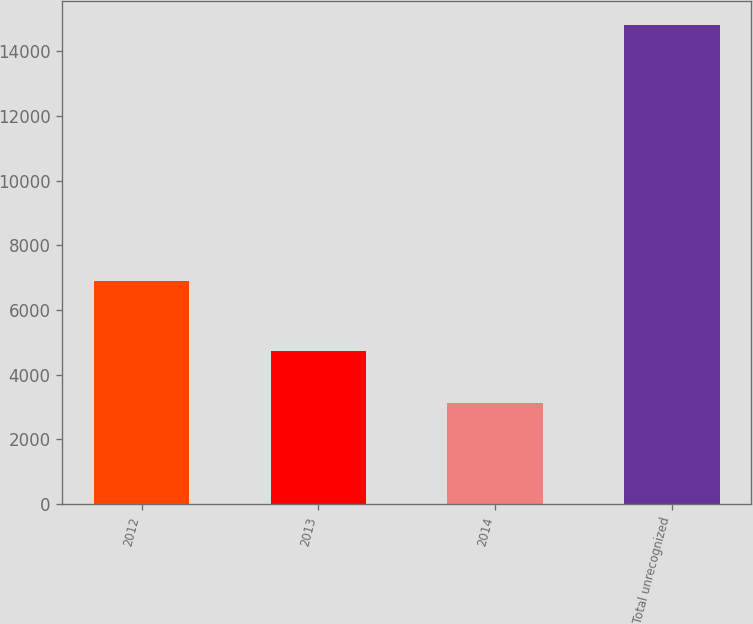<chart> <loc_0><loc_0><loc_500><loc_500><bar_chart><fcel>2012<fcel>2013<fcel>2014<fcel>Total unrecognized<nl><fcel>6883<fcel>4722<fcel>3116<fcel>14799<nl></chart> 